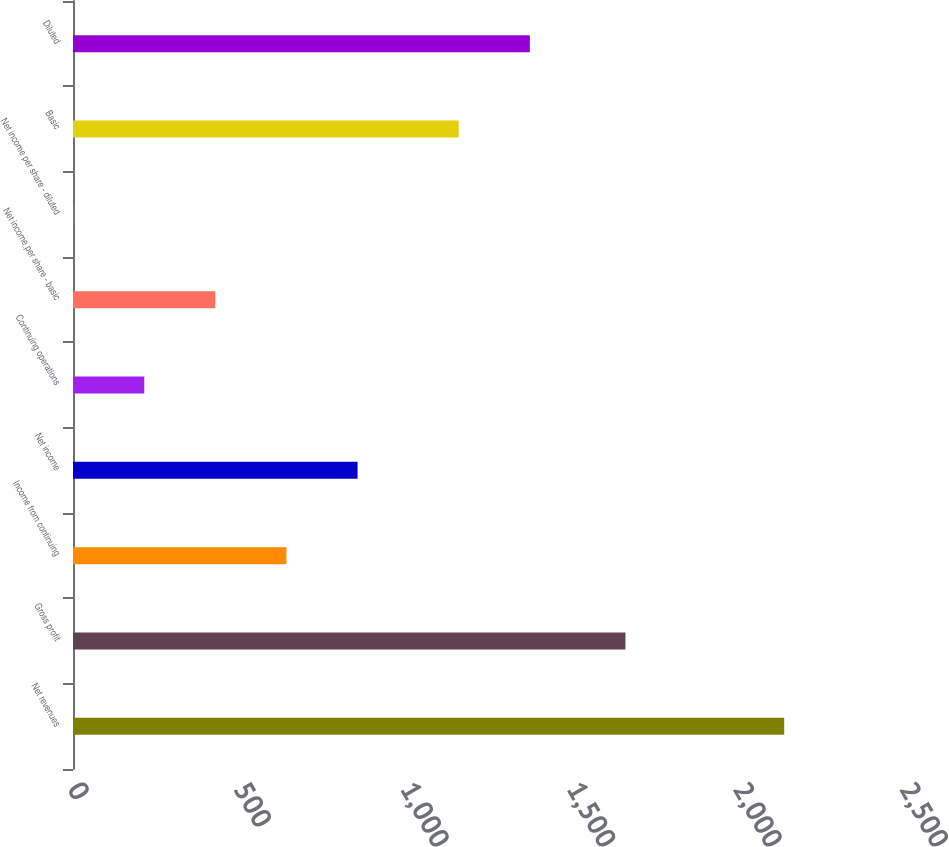<chart> <loc_0><loc_0><loc_500><loc_500><bar_chart><fcel>Net revenues<fcel>Gross profit<fcel>Income from continuing<fcel>Net income<fcel>Continuing operations<fcel>Net income per share - basic<fcel>Net income per share - diluted<fcel>Basic<fcel>Diluted<nl><fcel>2137<fcel>1660<fcel>641.39<fcel>855.05<fcel>214.07<fcel>427.73<fcel>0.41<fcel>1159<fcel>1372.66<nl></chart> 